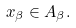<formula> <loc_0><loc_0><loc_500><loc_500>x _ { \beta } \in A _ { \beta } .</formula> 